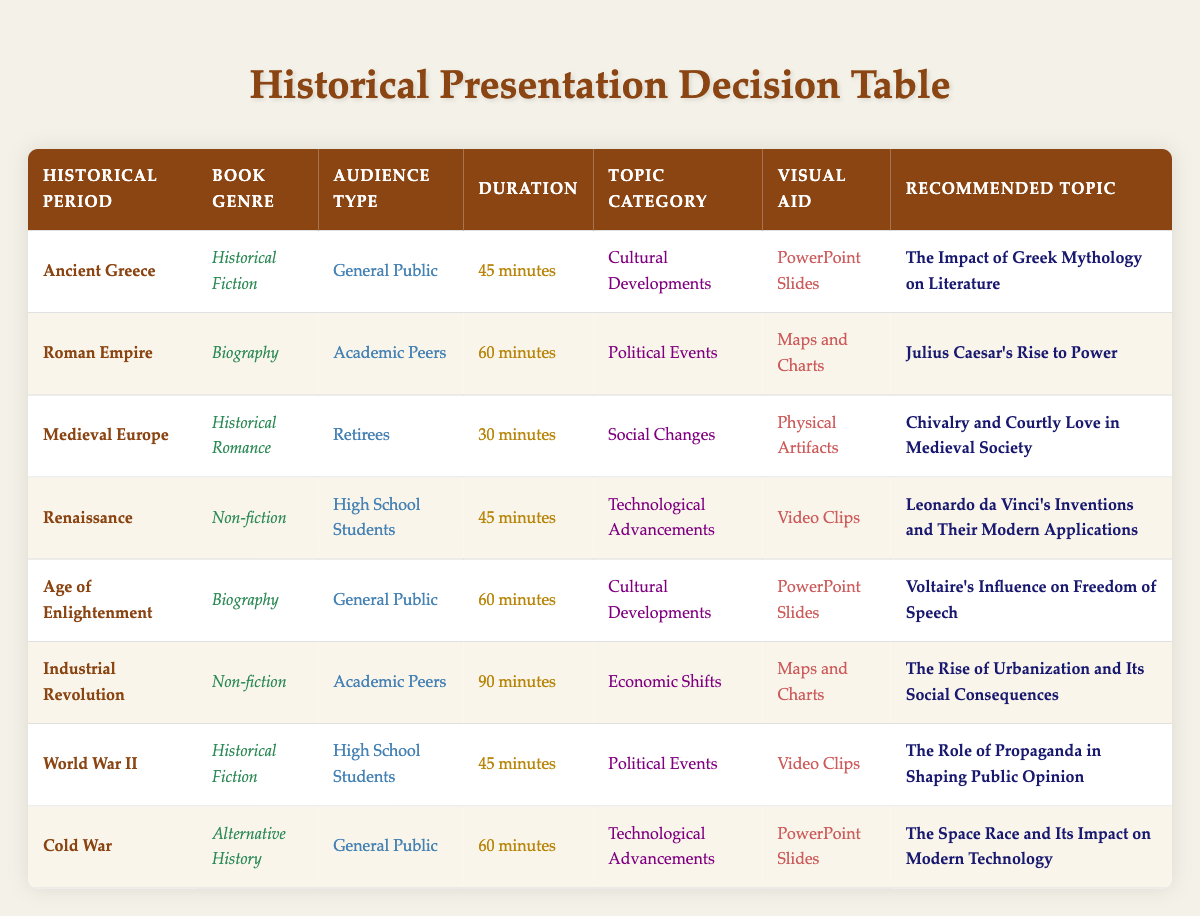What is the topic recommended for the Ancient Greece period? The table shows that for the historical period of Ancient Greece, the recommended topic is "The Impact of Greek Mythology on Literature."
Answer: The Impact of Greek Mythology on Literature Which visual aid is proposed for the topic on Julius Caesar’s rise to power? According to the table, the visual aid suggested for the topic "Julius Caesar's Rise to Power" during the Roman Empire period is "Maps and Charts."
Answer: Maps and Charts How many topics are recommended for the audience type "High School Students"? By looking at the table, there are 2 topics recommended for the audience type "High School Students": "Leonardo da Vinci's Inventions and Their Modern Applications" and "The Role of Propaganda in Shaping Public Opinion." Therefore, the total is 2.
Answer: 2 Is there a recommended topic for the Industrial Revolution that focuses on social changes? Upon checking the table, the recommended topic for the Industrial Revolution is "The Rise of Urbanization and Its Social Consequences," which falls under economic shifts, not social changes. Therefore, the answer is no.
Answer: No What presentation duration is most commonly associated with the general public audience? The table indicates that there are three topics related to the audience type "General Public" with the following durations: Ancient Greece (45 minutes), Age of Enlightenment (60 minutes), and Cold War (60 minutes). The most common duration for these topics is 60 minutes, as it appears twice.
Answer: 60 minutes What is the recommended topic that uses video clips as a visual aid? Looking through the table, two recommended topics are associated with the use of video clips: "Leonardo da Vinci's Inventions and Their Modern Applications" for the Renaissance and "The Role of Propaganda in Shaping Public Opinion" for World War II.
Answer: Leonardo da Vinci's Inventions and Their Modern Applications What are the recommended topics for the Medieval Europe period? The table details that for Medieval Europe, the recommended topic is "Chivalry and Courtly Love in Medieval Society." There are no additional topics associated with this period.
Answer: Chivalry and Courtly Love in Medieval Society How many of the recommended topics are related to Cultural Developments? Reviewing the table reveals that there are three topics classified under Cultural Developments: "The Impact of Greek Mythology on Literature," "Voltaire's Influence on Freedom of Speech," and "The Space Race and Its Impact on Modern Technology." Adding these gives us a total of 3.
Answer: 3 Which genre has the longest presentation duration? From the table, the Industrial Revolution is associated with the non-fiction genre and has the longest presentation duration of 90 minutes. No other genre exceeds this duration.
Answer: Non-fiction 